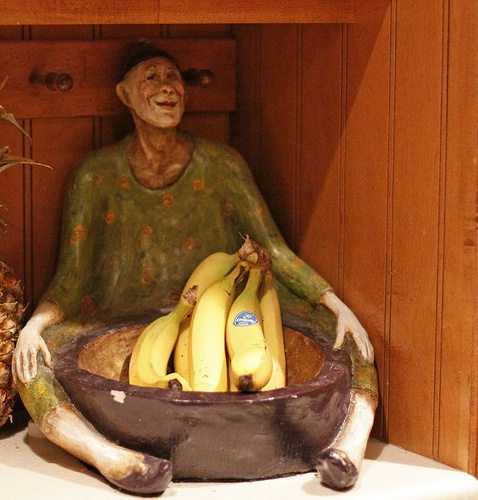Describe the objects in this image and their specific colors. I can see bowl in brown and maroon tones and banana in brown, khaki, gold, orange, and olive tones in this image. 